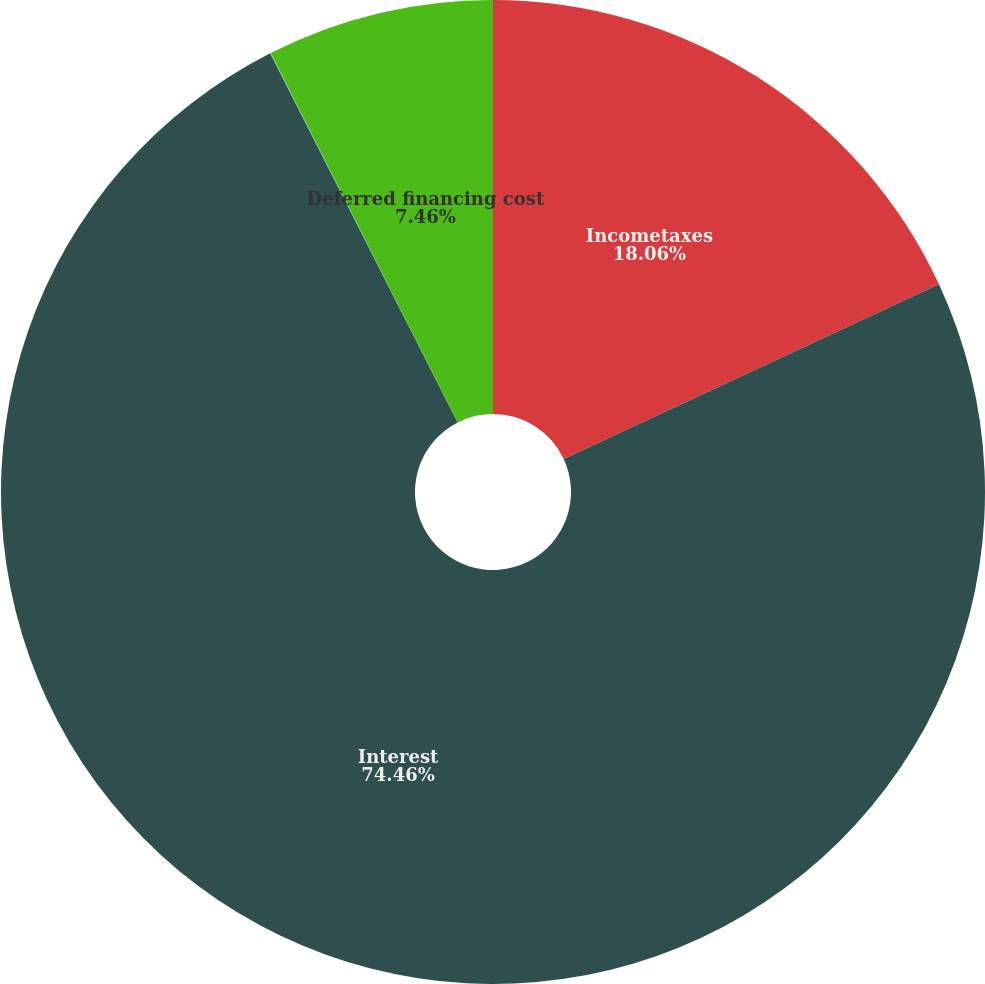Convert chart to OTSL. <chart><loc_0><loc_0><loc_500><loc_500><pie_chart><fcel>Incometaxes<fcel>Interest<fcel>Contributions to consolidated<fcel>Deferred financing cost<nl><fcel>18.06%<fcel>74.46%<fcel>0.02%<fcel>7.46%<nl></chart> 